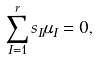Convert formula to latex. <formula><loc_0><loc_0><loc_500><loc_500>\sum _ { I = 1 } ^ { r } s _ { I } \mu _ { I } = 0 ,</formula> 